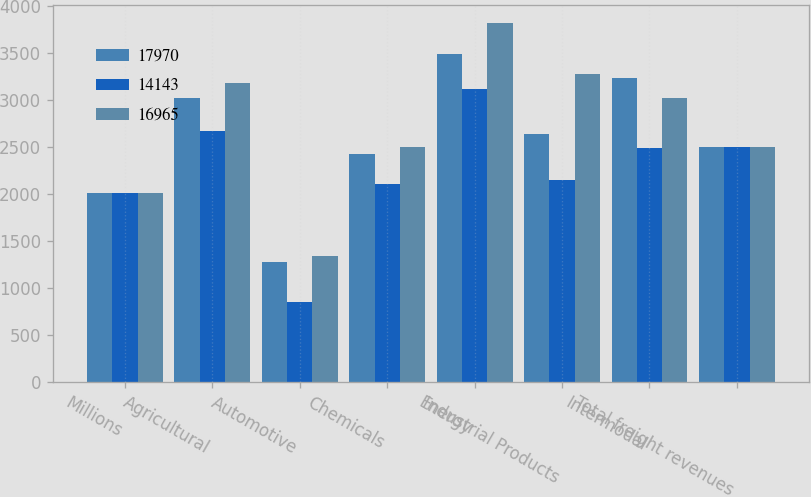Convert chart. <chart><loc_0><loc_0><loc_500><loc_500><stacked_bar_chart><ecel><fcel>Millions<fcel>Agricultural<fcel>Automotive<fcel>Chemicals<fcel>Energy<fcel>Industrial Products<fcel>Intermodal<fcel>Total freight revenues<nl><fcel>17970<fcel>2010<fcel>3018<fcel>1271<fcel>2425<fcel>3489<fcel>2639<fcel>3227<fcel>2494<nl><fcel>14143<fcel>2009<fcel>2666<fcel>854<fcel>2102<fcel>3118<fcel>2147<fcel>2486<fcel>2494<nl><fcel>16965<fcel>2008<fcel>3174<fcel>1344<fcel>2494<fcel>3810<fcel>3273<fcel>3023<fcel>2494<nl></chart> 